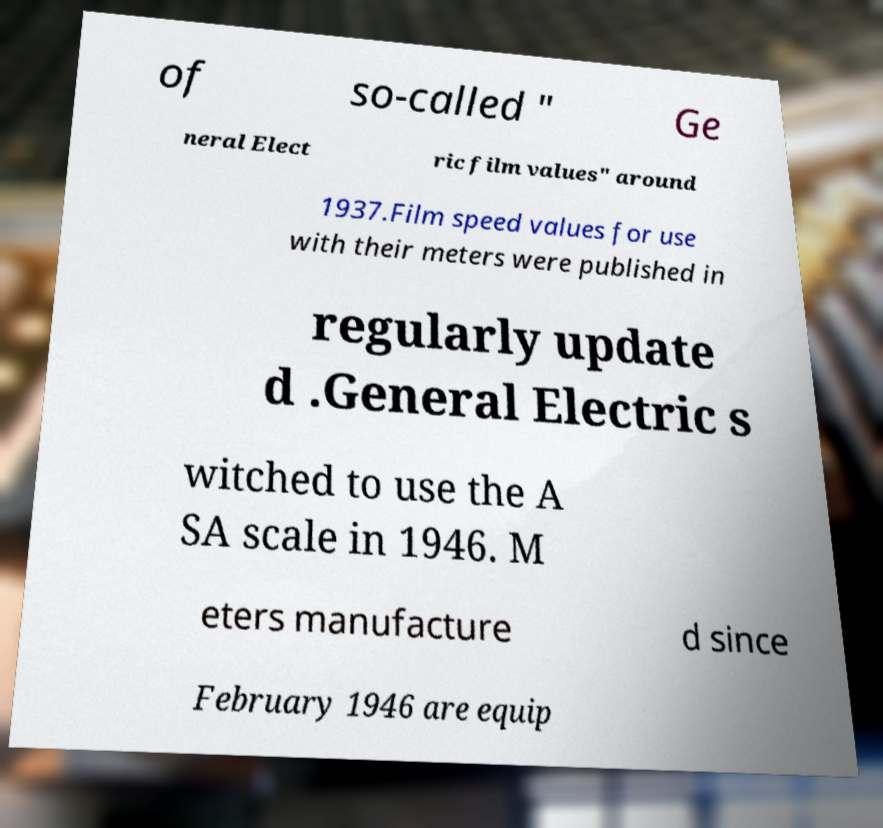There's text embedded in this image that I need extracted. Can you transcribe it verbatim? of so-called " Ge neral Elect ric film values" around 1937.Film speed values for use with their meters were published in regularly update d .General Electric s witched to use the A SA scale in 1946. M eters manufacture d since February 1946 are equip 